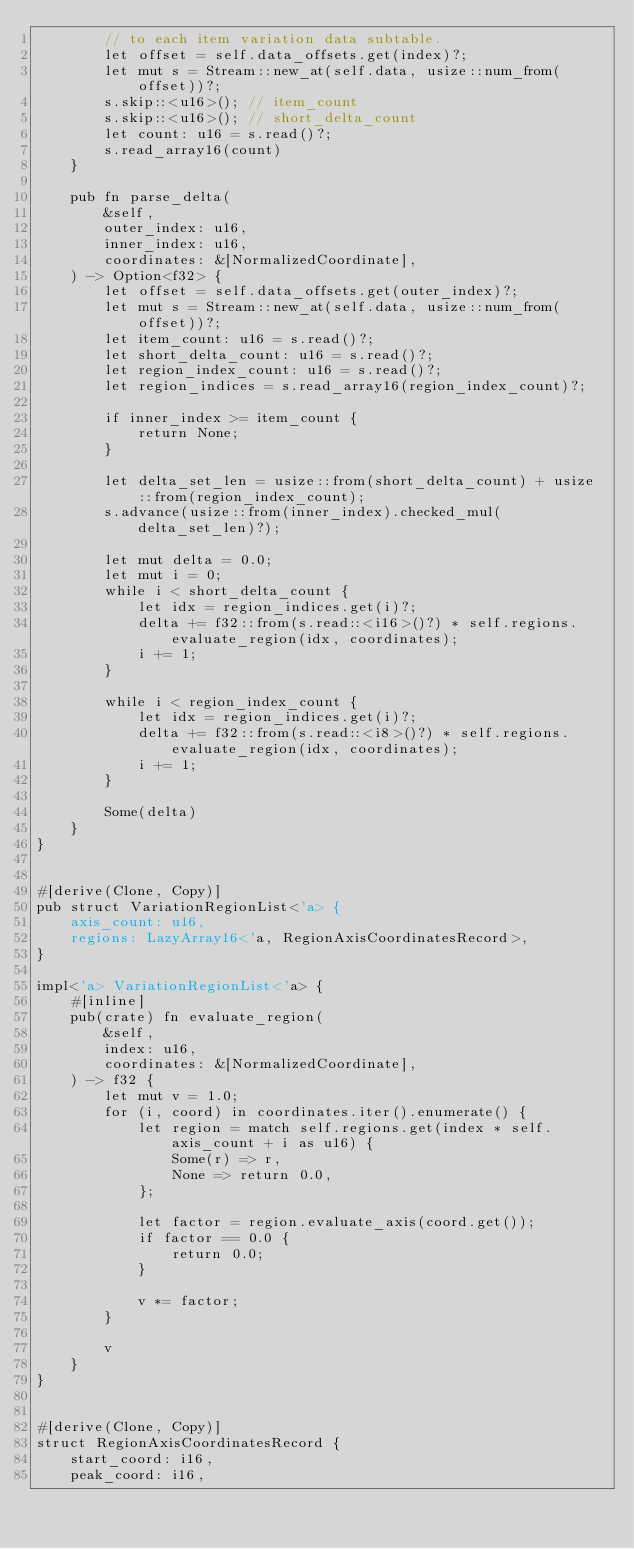<code> <loc_0><loc_0><loc_500><loc_500><_Rust_>        // to each item variation data subtable.
        let offset = self.data_offsets.get(index)?;
        let mut s = Stream::new_at(self.data, usize::num_from(offset))?;
        s.skip::<u16>(); // item_count
        s.skip::<u16>(); // short_delta_count
        let count: u16 = s.read()?;
        s.read_array16(count)
    }

    pub fn parse_delta(
        &self,
        outer_index: u16,
        inner_index: u16,
        coordinates: &[NormalizedCoordinate],
    ) -> Option<f32> {
        let offset = self.data_offsets.get(outer_index)?;
        let mut s = Stream::new_at(self.data, usize::num_from(offset))?;
        let item_count: u16 = s.read()?;
        let short_delta_count: u16 = s.read()?;
        let region_index_count: u16 = s.read()?;
        let region_indices = s.read_array16(region_index_count)?;

        if inner_index >= item_count {
            return None;
        }

        let delta_set_len = usize::from(short_delta_count) + usize::from(region_index_count);
        s.advance(usize::from(inner_index).checked_mul(delta_set_len)?);

        let mut delta = 0.0;
        let mut i = 0;
        while i < short_delta_count {
            let idx = region_indices.get(i)?;
            delta += f32::from(s.read::<i16>()?) * self.regions.evaluate_region(idx, coordinates);
            i += 1;
        }

        while i < region_index_count {
            let idx = region_indices.get(i)?;
            delta += f32::from(s.read::<i8>()?) * self.regions.evaluate_region(idx, coordinates);
            i += 1;
        }

        Some(delta)
    }
}


#[derive(Clone, Copy)]
pub struct VariationRegionList<'a> {
    axis_count: u16,
    regions: LazyArray16<'a, RegionAxisCoordinatesRecord>,
}

impl<'a> VariationRegionList<'a> {
    #[inline]
    pub(crate) fn evaluate_region(
        &self,
        index: u16,
        coordinates: &[NormalizedCoordinate],
    ) -> f32 {
        let mut v = 1.0;
        for (i, coord) in coordinates.iter().enumerate() {
            let region = match self.regions.get(index * self.axis_count + i as u16) {
                Some(r) => r,
                None => return 0.0,
            };

            let factor = region.evaluate_axis(coord.get());
            if factor == 0.0 {
                return 0.0;
            }

            v *= factor;
        }

        v
    }
}


#[derive(Clone, Copy)]
struct RegionAxisCoordinatesRecord {
    start_coord: i16,
    peak_coord: i16,</code> 